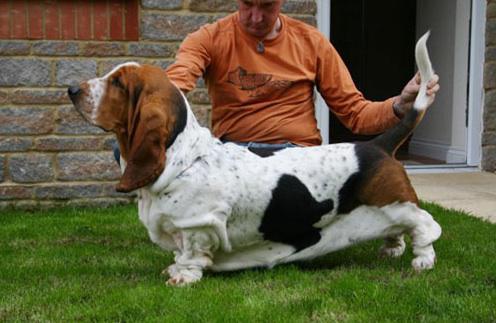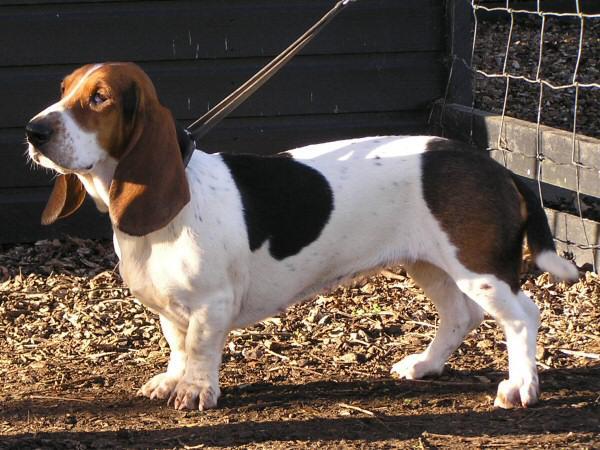The first image is the image on the left, the second image is the image on the right. Given the left and right images, does the statement "One dog is standing by itself with its tail up in the air." hold true? Answer yes or no. No. The first image is the image on the left, the second image is the image on the right. Given the left and right images, does the statement "In one image there is a lone basset hound standing outside facing the left side of the image." hold true? Answer yes or no. Yes. 